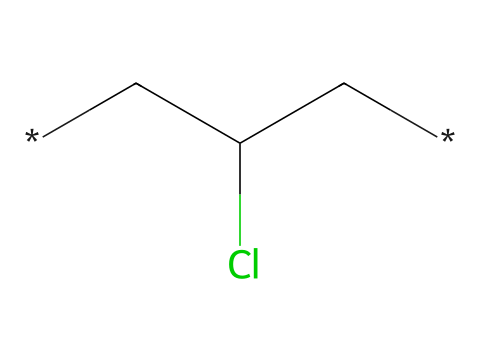What is the main element in this chemical structure? The chemical structure shows a chlorine atom (Cl) bonded to a carbon structure (C), indicating that chlorine is a significant element in polyvinyl chloride (PVC).
Answer: chlorine How many carbon atoms are present in this chemical? The SMILES representation indicates two carbon atoms (C) in the structure, which are the backbone of polyvinyl chloride.
Answer: two What type of bonds are present in this chemical? The representation shows single bonds between carbon atoms and the chlorine atom, characteristic of saturated organic compounds like PVC.
Answer: single bonds What does the presence of chlorine suggest about the properties of this chemical? Chlorine introduces polarity and enhances resistance to combustion in the polymer, making it suitable for outdoor applications like banners.
Answer: enhanced durability Is this chemical a polymer? The presence of repeating units of the carbon structure with chlorine suggests that it is indeed a polymer, specifically polyvinyl chloride.
Answer: yes What feature makes PVC suitable for weather-resistant applications? PVC's chemical structure contributes to its resistance to moisture and UV light, making it an ideal choice for outdoor banners.
Answer: moisture and UV resistance How does the chlorine atom affect the flexibility of this plastic? The chlorine atom increases the rigidity of the molecular structure, limiting flexibility but enhancing durability in outdoor environments.
Answer: increases rigidity 